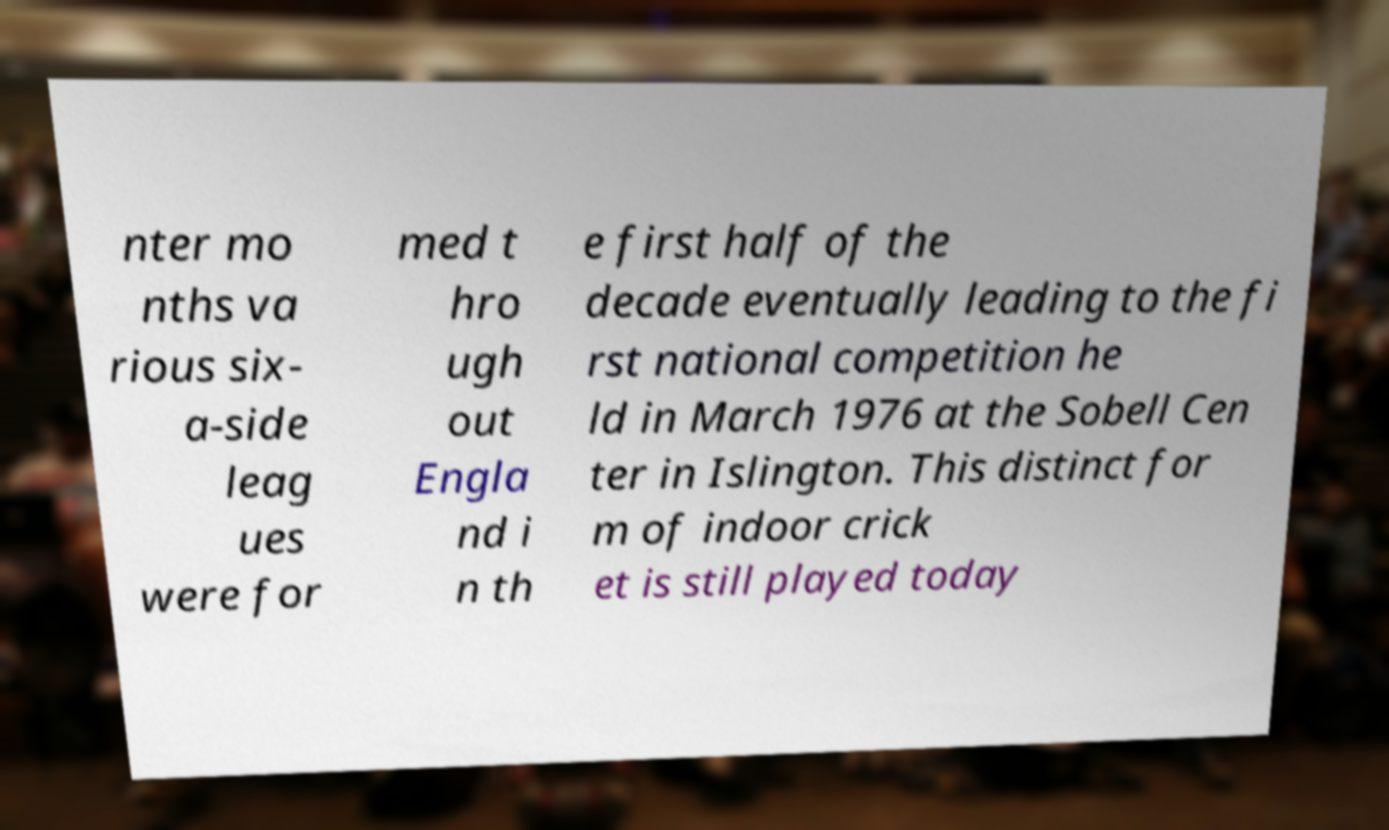Can you accurately transcribe the text from the provided image for me? nter mo nths va rious six- a-side leag ues were for med t hro ugh out Engla nd i n th e first half of the decade eventually leading to the fi rst national competition he ld in March 1976 at the Sobell Cen ter in Islington. This distinct for m of indoor crick et is still played today 